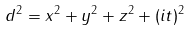Convert formula to latex. <formula><loc_0><loc_0><loc_500><loc_500>d ^ { 2 } = x ^ { 2 } + y ^ { 2 } + z ^ { 2 } + ( i t ) ^ { 2 }</formula> 